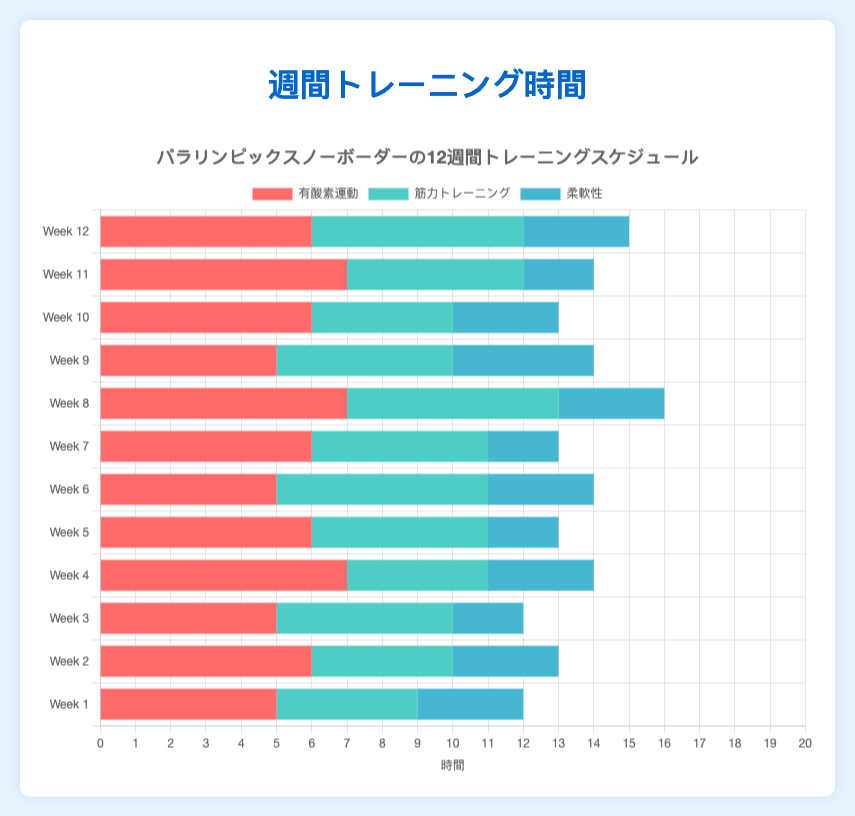What week had the highest total training hours? To find the week with the highest total training hours, we need to sum the hours for cardio, strength, and flexibility for each week and identify the maximum. Week 4 and Week 8 each have: 7 (Cardio) + 4 (Strength) + 3 (Flexibility) = 14 hours. Week 8 has: 7 (Cardio) + 6 (Strength) + 3 (Flexibility) = 16 hours. Therefore, Week 8 has the highest total training hours.
Answer: Week 8 What is the average number of hours spent on strength training per week? Sum the hours for strength training across all weeks and divide by 12. (4 + 4 + 5 + 4 + 5 + 6 + 5 + 6 + 5 + 4 + 5 + 6) / 12 = 59 / 12 = 4.92 hours
Answer: 4.92 Comparing Week 3 and Week 6, which week had more flexibility training? By examining the figure, we see that Week 3 had 2 hours of flexibility training, and Week 6 had 3 hours of flexibility training. Therefore, Week 6 had more flexibility training.
Answer: Week 6 What is the total number of hours spent on cardio training over the 12 weeks? Sum the hours for cardio across all weeks. 5 + 6 + 5 + 7 + 6 + 5 + 6 + 7 + 5 + 6 + 7 + 6 = 71 hours
Answer: 71 What was the difference in total training hours between Week 7 and Week 9? To find the difference in total training hours, we sum the hours for each week and subtract Week 9's total from Week 7's total. Week 7: 6 (Cardio) + 5 (Strength) + 2 (Flexibility) = 13 hours. Week 9: 5 (Cardio) + 5 (Strength) + 4 (Flexibility) = 14 hours. Difference = 14 - 13 = 1 hour
Answer: 1 Which week had equal hours spent on strength and flexibility training? Checking visually, Week 1, Week 2, Week 4, Week 10, and Week 12 have 4 hours of strength and 3 hours of flexibility, which visually differ. Therefore, no weeks had equal hours for strength and flexibility training.
Answer: None What is the average total training hours per week? First, sum the total training hours for all weeks, then divide by the number of weeks. Sum = (5+4+3) + (6+4+3) + (5+5+2) + (7+4+3) + (6+5+2) + (5+6+3) + (6+5+2) + (7+6+3) + (5+5+4) + (6+4+3) + (7+5+2) + (6+6+3) = 148 hours. Average = 148 / 12 = 12.33 hours
Answer: 12.33 Which week had the least hours of cardio training? Visually inspecting the chart, Week 1, Week 3, Week 6, and Week 9 each show 5 hours of cardio training, which is the minimum across all weeks.
Answer: Weeks 1, 3, 6, 9 